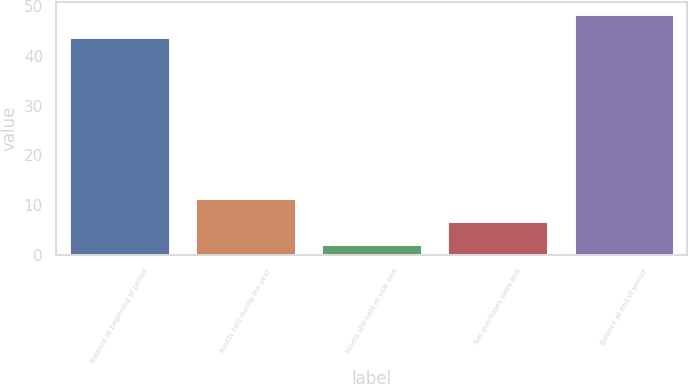Convert chart. <chart><loc_0><loc_0><loc_500><loc_500><bar_chart><fcel>Balance at beginning of period<fcel>Assets sold during the year<fcel>Assets still held at year end<fcel>Net purchases sales and<fcel>Balance at end of period<nl><fcel>43.8<fcel>11.4<fcel>2.2<fcel>6.8<fcel>48.4<nl></chart> 